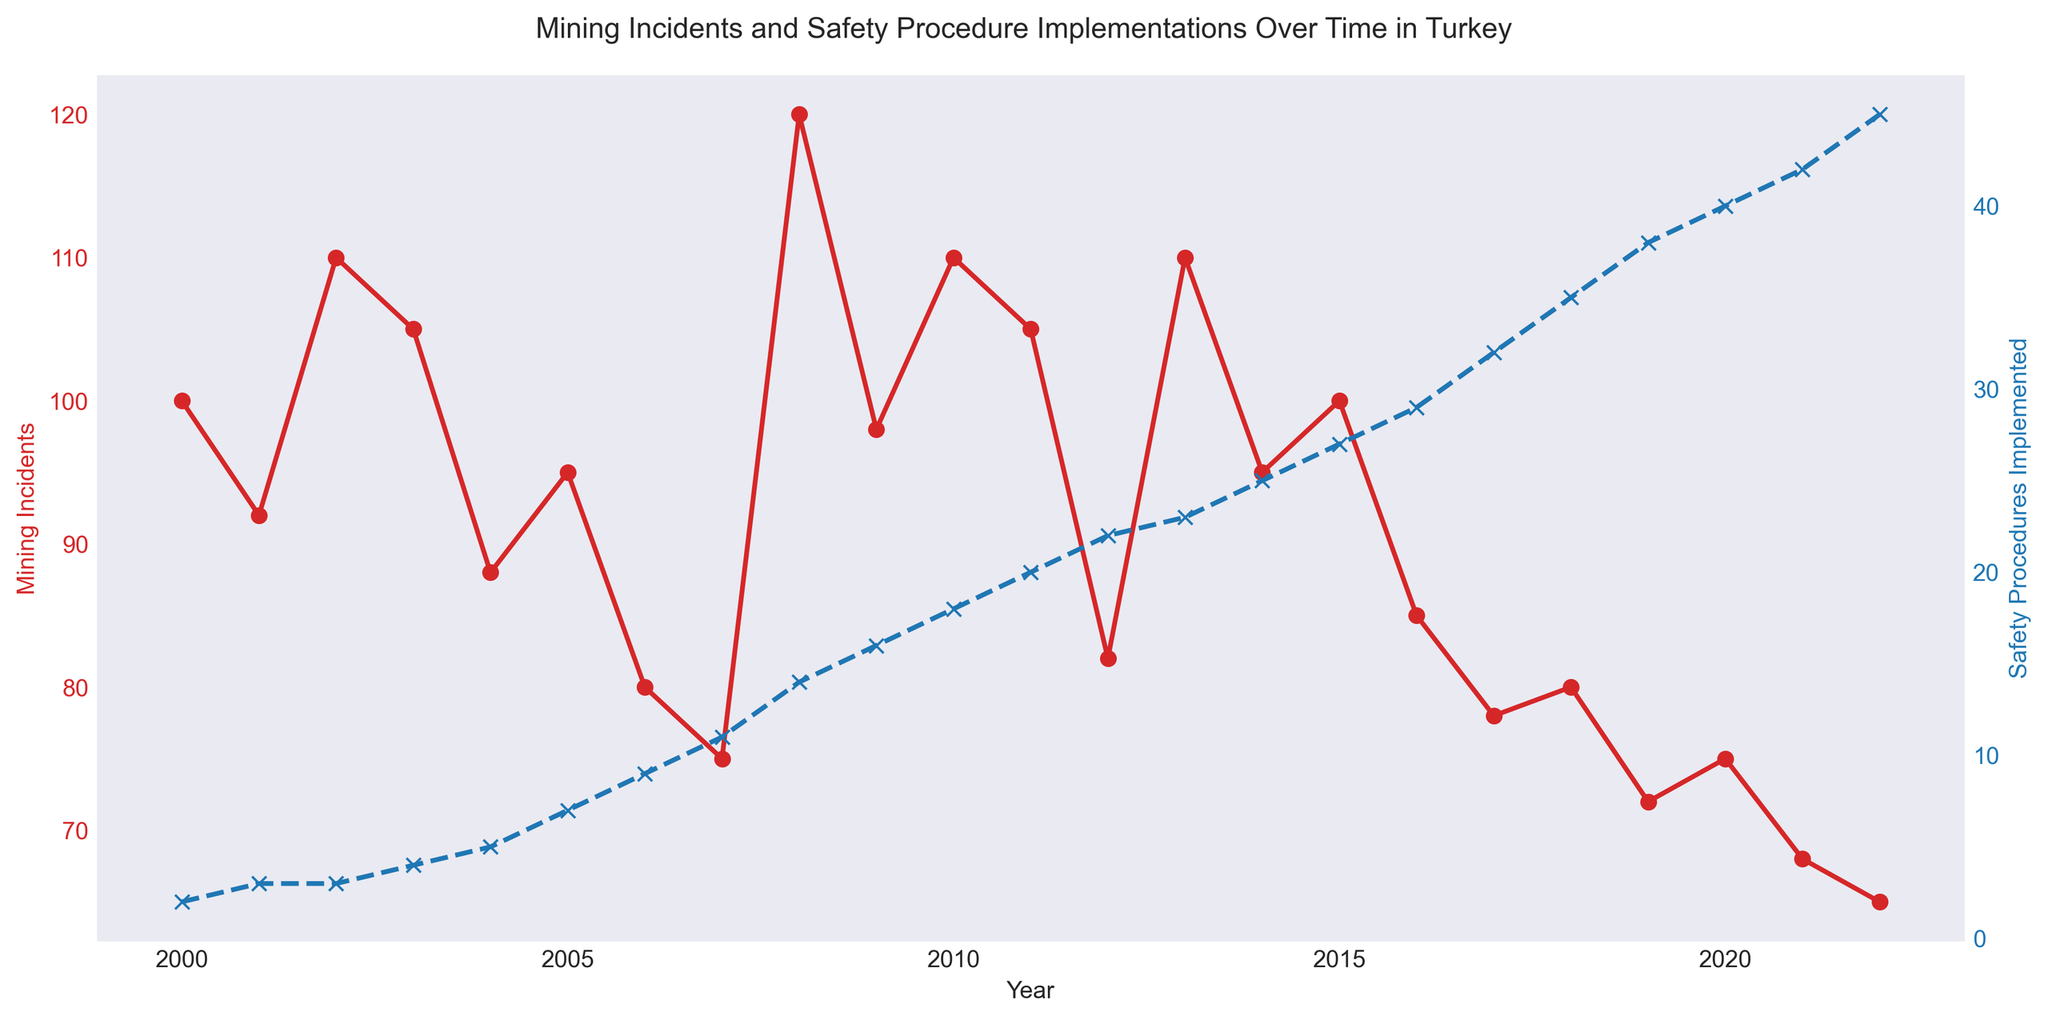What is the overall trend of mining incidents from 2000 to 2022? To determine the trend of mining incidents over the years, observe the red line in the figure. Initially, there was a decrease from 2000 to 2004. This was followed by fluctuations with a noticeable increase in 2008 and subsequent decreases with slight fluctuations, ending with a decrease up to 2022.
Answer: General decrease with some fluctuations How many years saw mining incidents above 100? We need to count the number of years where the red line representing mining incidents is above the 100 mark. Visually, these years are 2002, 2003, 2008, 2010, 2013, and possibly 2000. By counting, we get 6 years.
Answer: 6 years What can be said about the relation between the number of safety procedures implemented and mining incidents over time? By examining the blue and red lines together, it is observable that as the number of safety procedures implemented (blue line) generally increase, the number of mining incidents (red line) shows a general trend of decrease, suggesting an inverse relationship.
Answer: Inverse relationship Which year had the highest number of mining incidents and what was the implemented safety procedure count in that year? Identify the peak of the red line, which is in 2008 with 120 mining incidents. The blue line indicates around that point that 14 safety procedures were implemented.
Answer: 2008 with 120 incidents and 14 safety procedures In what year were the safety procedures implemented first recorded as greater than 30? Observe the blue line crossing the 30 mark for the first time; it appears to be in the year 2017.
Answer: 2017 How does the number of mining incidents in 2022 compare to the number in 2000? Compare the height of the red line at the starting point (2000) and the ending point (2022). The incidents in 2000 were 100, and in 2022, they reduced to 65.
Answer: 2022 had 35 fewer incidents Calculate the average number of mining incidents from 2015 to 2022. Sum the mining incidents from 2015 to 2022 (100, 85, 78, 80, 72, 75, 68, 65) and divide by the number of years (8). Sum is 623, thus the average is 623/8.
Answer: 77.875 Which year had the sharpest drop in the number of mining incidents compared to the previous year? Look for the largest vertical drop between two consecutive red plot points. The sharpest drop appears to be between 2013 (110) and 2014 (95), which is a drop of 15 incidents.
Answer: 2013 to 2014 How many safety procedures were implemented in the year with the minimum number of mining incidents? Identify the lowest point on the red line, which is in 2022 with 65 incidents. Note the corresponding count on the blue line, which is approximately 45 safety procedures.
Answer: 45 What is the percentage change in mining incidents from 2000 to 2022? Calculate the difference between the incidents in 2000 and 2022 (100 in 2000 and 65 in 2022), which is 35. Then, divide it by the initial value (100) and multiply by 100 to get the percentage change. (35/100) * 100.
Answer: 35% decrease 